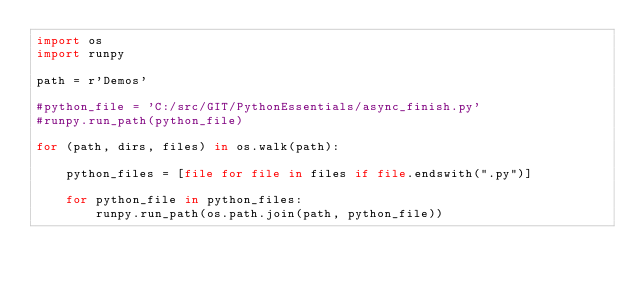Convert code to text. <code><loc_0><loc_0><loc_500><loc_500><_Python_>import os
import runpy

path = r'Demos'

#python_file = 'C:/src/GIT/PythonEssentials/async_finish.py'
#runpy.run_path(python_file)

for (path, dirs, files) in os.walk(path):

    python_files = [file for file in files if file.endswith(".py")]
    
    for python_file in python_files:
        runpy.run_path(os.path.join(path, python_file))
</code> 